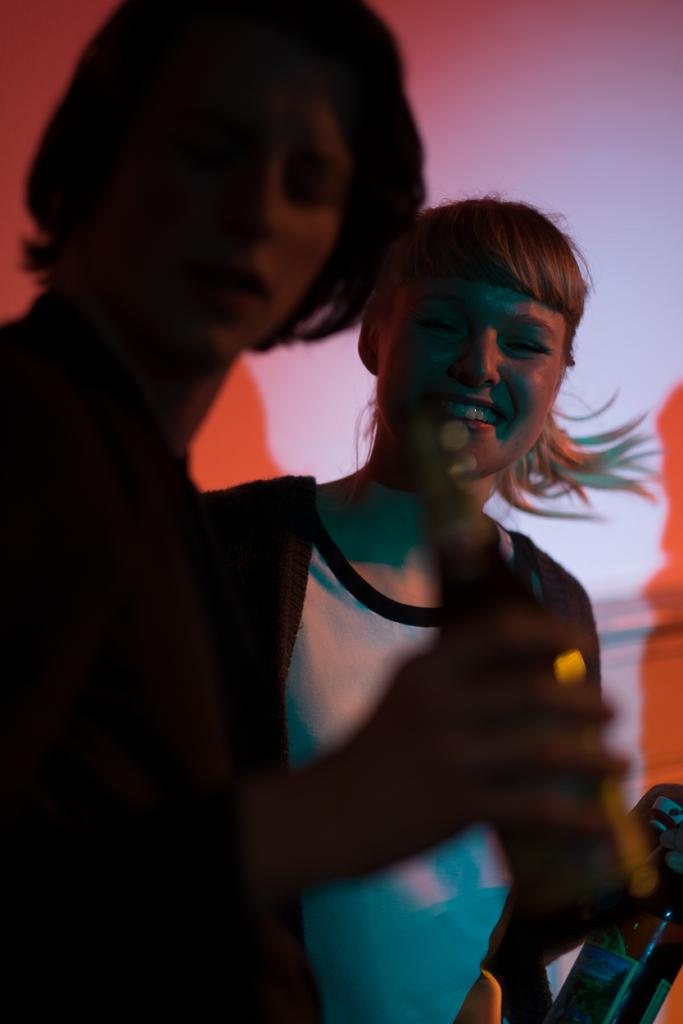How many people are in the image? There are two people in the foreground of the image. What is one person holding in the image? One person is holding a bottle. What type of boat can be seen in the image? There is no boat present in the image. How many knots are tied on the coat in the image? There is no coat or knots present in the image. 